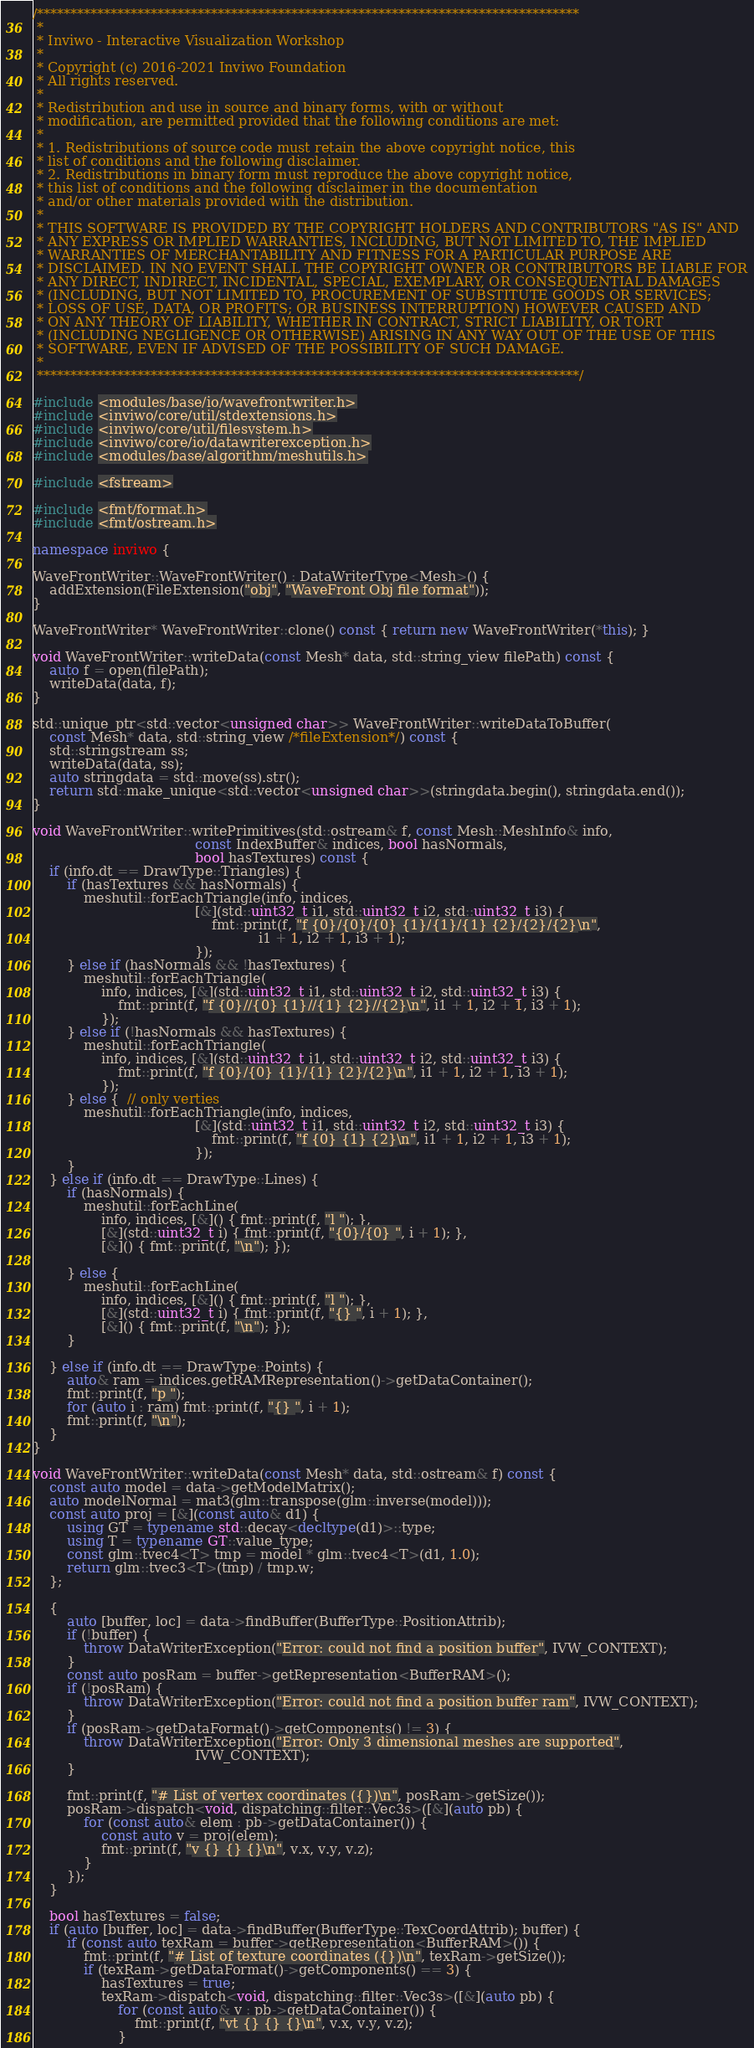Convert code to text. <code><loc_0><loc_0><loc_500><loc_500><_C++_>/*********************************************************************************
 *
 * Inviwo - Interactive Visualization Workshop
 *
 * Copyright (c) 2016-2021 Inviwo Foundation
 * All rights reserved.
 *
 * Redistribution and use in source and binary forms, with or without
 * modification, are permitted provided that the following conditions are met:
 *
 * 1. Redistributions of source code must retain the above copyright notice, this
 * list of conditions and the following disclaimer.
 * 2. Redistributions in binary form must reproduce the above copyright notice,
 * this list of conditions and the following disclaimer in the documentation
 * and/or other materials provided with the distribution.
 *
 * THIS SOFTWARE IS PROVIDED BY THE COPYRIGHT HOLDERS AND CONTRIBUTORS "AS IS" AND
 * ANY EXPRESS OR IMPLIED WARRANTIES, INCLUDING, BUT NOT LIMITED TO, THE IMPLIED
 * WARRANTIES OF MERCHANTABILITY AND FITNESS FOR A PARTICULAR PURPOSE ARE
 * DISCLAIMED. IN NO EVENT SHALL THE COPYRIGHT OWNER OR CONTRIBUTORS BE LIABLE FOR
 * ANY DIRECT, INDIRECT, INCIDENTAL, SPECIAL, EXEMPLARY, OR CONSEQUENTIAL DAMAGES
 * (INCLUDING, BUT NOT LIMITED TO, PROCUREMENT OF SUBSTITUTE GOODS OR SERVICES;
 * LOSS OF USE, DATA, OR PROFITS; OR BUSINESS INTERRUPTION) HOWEVER CAUSED AND
 * ON ANY THEORY OF LIABILITY, WHETHER IN CONTRACT, STRICT LIABILITY, OR TORT
 * (INCLUDING NEGLIGENCE OR OTHERWISE) ARISING IN ANY WAY OUT OF THE USE OF THIS
 * SOFTWARE, EVEN IF ADVISED OF THE POSSIBILITY OF SUCH DAMAGE.
 *
 *********************************************************************************/

#include <modules/base/io/wavefrontwriter.h>
#include <inviwo/core/util/stdextensions.h>
#include <inviwo/core/util/filesystem.h>
#include <inviwo/core/io/datawriterexception.h>
#include <modules/base/algorithm/meshutils.h>

#include <fstream>

#include <fmt/format.h>
#include <fmt/ostream.h>

namespace inviwo {

WaveFrontWriter::WaveFrontWriter() : DataWriterType<Mesh>() {
    addExtension(FileExtension("obj", "WaveFront Obj file format"));
}

WaveFrontWriter* WaveFrontWriter::clone() const { return new WaveFrontWriter(*this); }

void WaveFrontWriter::writeData(const Mesh* data, std::string_view filePath) const {
    auto f = open(filePath);
    writeData(data, f);
}

std::unique_ptr<std::vector<unsigned char>> WaveFrontWriter::writeDataToBuffer(
    const Mesh* data, std::string_view /*fileExtension*/) const {
    std::stringstream ss;
    writeData(data, ss);
    auto stringdata = std::move(ss).str();
    return std::make_unique<std::vector<unsigned char>>(stringdata.begin(), stringdata.end());
}

void WaveFrontWriter::writePrimitives(std::ostream& f, const Mesh::MeshInfo& info,
                                      const IndexBuffer& indices, bool hasNormals,
                                      bool hasTextures) const {
    if (info.dt == DrawType::Triangles) {
        if (hasTextures && hasNormals) {
            meshutil::forEachTriangle(info, indices,
                                      [&](std::uint32_t i1, std::uint32_t i2, std::uint32_t i3) {
                                          fmt::print(f, "f {0}/{0}/{0} {1}/{1}/{1} {2}/{2}/{2}\n",
                                                     i1 + 1, i2 + 1, i3 + 1);
                                      });
        } else if (hasNormals && !hasTextures) {
            meshutil::forEachTriangle(
                info, indices, [&](std::uint32_t i1, std::uint32_t i2, std::uint32_t i3) {
                    fmt::print(f, "f {0}//{0} {1}//{1} {2}//{2}\n", i1 + 1, i2 + 1, i3 + 1);
                });
        } else if (!hasNormals && hasTextures) {
            meshutil::forEachTriangle(
                info, indices, [&](std::uint32_t i1, std::uint32_t i2, std::uint32_t i3) {
                    fmt::print(f, "f {0}/{0} {1}/{1} {2}/{2}\n", i1 + 1, i2 + 1, i3 + 1);
                });
        } else {  // only verties
            meshutil::forEachTriangle(info, indices,
                                      [&](std::uint32_t i1, std::uint32_t i2, std::uint32_t i3) {
                                          fmt::print(f, "f {0} {1} {2}\n", i1 + 1, i2 + 1, i3 + 1);
                                      });
        }
    } else if (info.dt == DrawType::Lines) {
        if (hasNormals) {
            meshutil::forEachLine(
                info, indices, [&]() { fmt::print(f, "l "); },
                [&](std::uint32_t i) { fmt::print(f, "{0}/{0} ", i + 1); },
                [&]() { fmt::print(f, "\n"); });

        } else {
            meshutil::forEachLine(
                info, indices, [&]() { fmt::print(f, "l "); },
                [&](std::uint32_t i) { fmt::print(f, "{} ", i + 1); },
                [&]() { fmt::print(f, "\n"); });
        }

    } else if (info.dt == DrawType::Points) {
        auto& ram = indices.getRAMRepresentation()->getDataContainer();
        fmt::print(f, "p ");
        for (auto i : ram) fmt::print(f, "{} ", i + 1);
        fmt::print(f, "\n");
    }
}

void WaveFrontWriter::writeData(const Mesh* data, std::ostream& f) const {
    const auto model = data->getModelMatrix();
    auto modelNormal = mat3(glm::transpose(glm::inverse(model)));
    const auto proj = [&](const auto& d1) {
        using GT = typename std::decay<decltype(d1)>::type;
        using T = typename GT::value_type;
        const glm::tvec4<T> tmp = model * glm::tvec4<T>(d1, 1.0);
        return glm::tvec3<T>(tmp) / tmp.w;
    };

    {
        auto [buffer, loc] = data->findBuffer(BufferType::PositionAttrib);
        if (!buffer) {
            throw DataWriterException("Error: could not find a position buffer", IVW_CONTEXT);
        }
        const auto posRam = buffer->getRepresentation<BufferRAM>();
        if (!posRam) {
            throw DataWriterException("Error: could not find a position buffer ram", IVW_CONTEXT);
        }
        if (posRam->getDataFormat()->getComponents() != 3) {
            throw DataWriterException("Error: Only 3 dimensional meshes are supported",
                                      IVW_CONTEXT);
        }

        fmt::print(f, "# List of vertex coordinates ({})\n", posRam->getSize());
        posRam->dispatch<void, dispatching::filter::Vec3s>([&](auto pb) {
            for (const auto& elem : pb->getDataContainer()) {
                const auto v = proj(elem);
                fmt::print(f, "v {} {} {}\n", v.x, v.y, v.z);
            }
        });
    }

    bool hasTextures = false;
    if (auto [buffer, loc] = data->findBuffer(BufferType::TexCoordAttrib); buffer) {
        if (const auto texRam = buffer->getRepresentation<BufferRAM>()) {
            fmt::print(f, "# List of texture coordinates ({})\n", texRam->getSize());
            if (texRam->getDataFormat()->getComponents() == 3) {
                hasTextures = true;
                texRam->dispatch<void, dispatching::filter::Vec3s>([&](auto pb) {
                    for (const auto& v : pb->getDataContainer()) {
                        fmt::print(f, "vt {} {} {}\n", v.x, v.y, v.z);
                    }</code> 